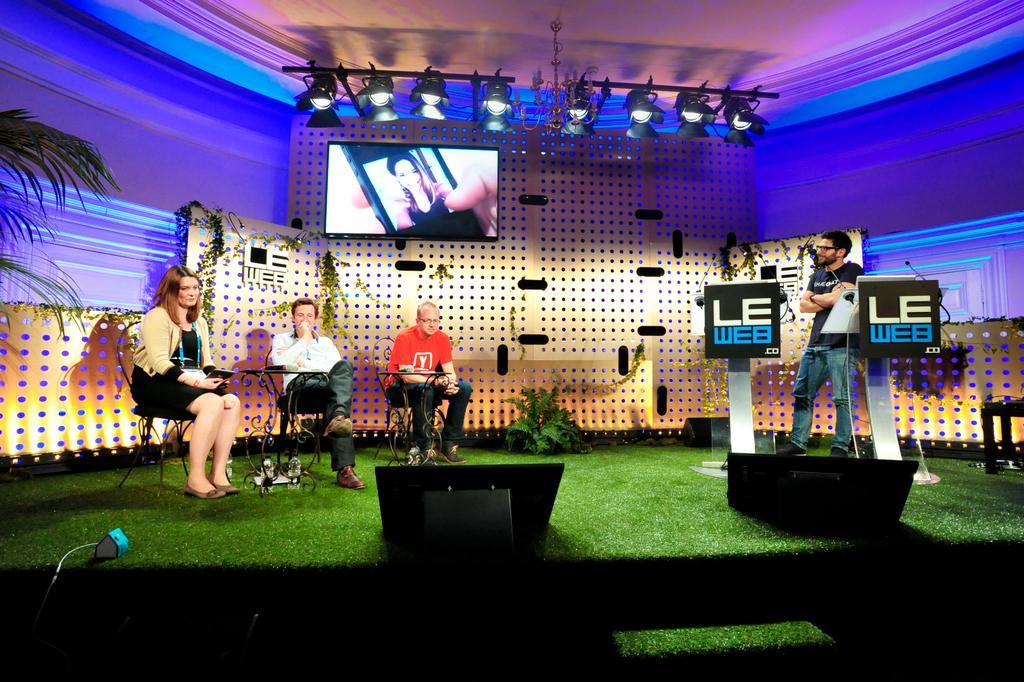In one or two sentences, can you explain what this image depicts? In this image, there are three persons sitting on the chairs and a person standing. I can see the tables, speakers, podium with boards and miles and there are few other objects on a carpet. In the background, there are focus lights, plants and television to a board. Behind the board, I can see a wall. 